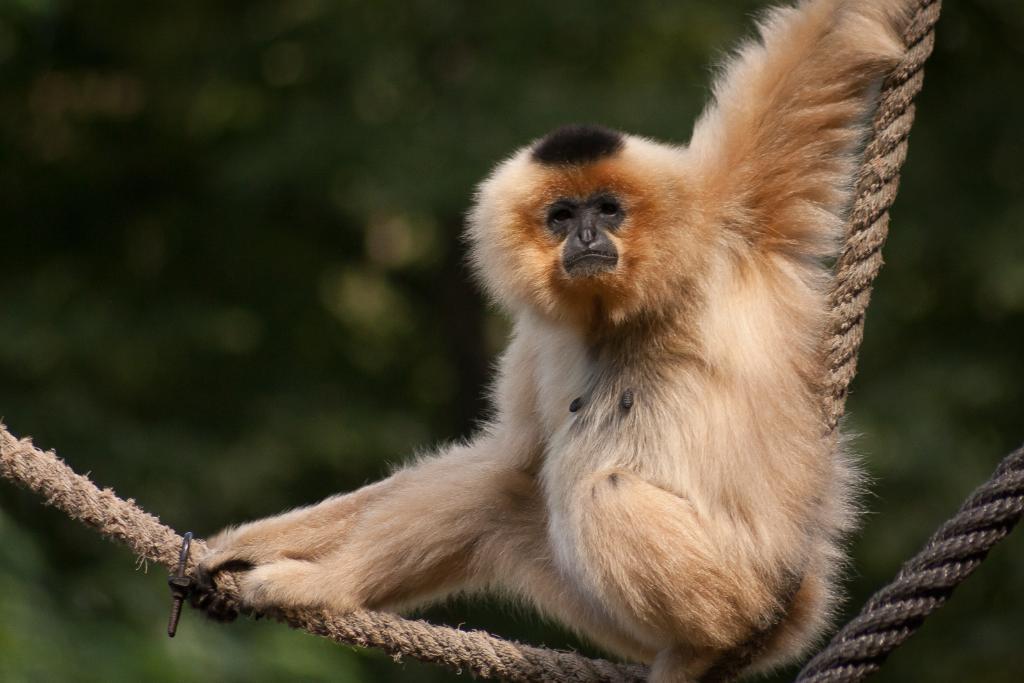How would you summarize this image in a sentence or two? In the image we can see a monkey, pale brown in color. Here we can see the ropes and the background is blurred. 